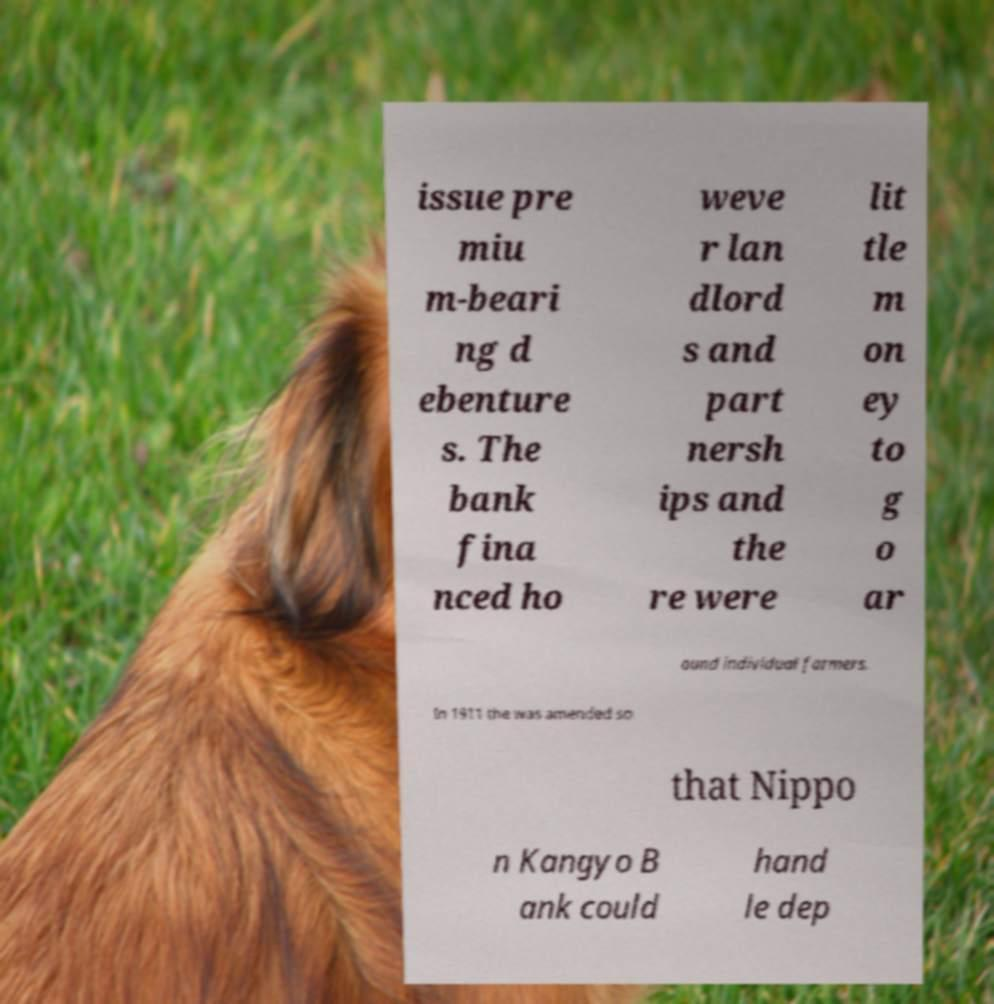Please identify and transcribe the text found in this image. issue pre miu m-beari ng d ebenture s. The bank fina nced ho weve r lan dlord s and part nersh ips and the re were lit tle m on ey to g o ar ound individual farmers. In 1911 the was amended so that Nippo n Kangyo B ank could hand le dep 